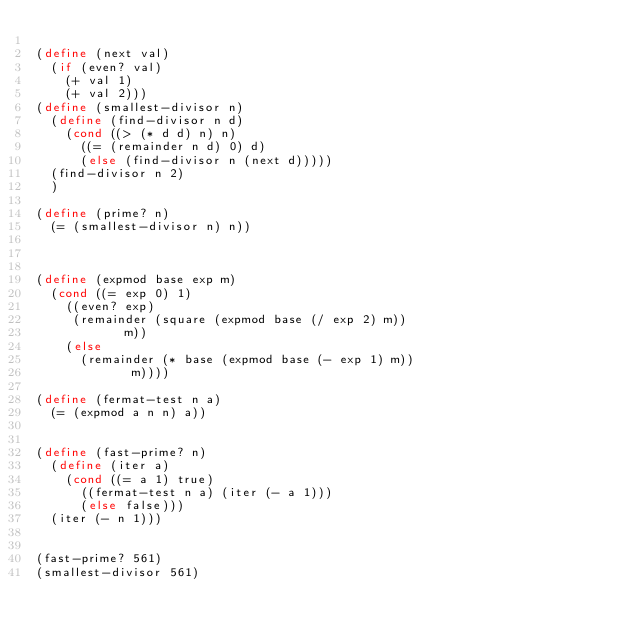<code> <loc_0><loc_0><loc_500><loc_500><_Scheme_>
(define (next val) 
  (if (even? val)
    (+ val 1)
    (+ val 2)))
(define (smallest-divisor n)
  (define (find-divisor n d)
    (cond ((> (* d d) n) n)
	  ((= (remainder n d) 0) d)
	  (else (find-divisor n (next d)))))
  (find-divisor n 2)
  )

(define (prime? n)
  (= (smallest-divisor n) n))



(define (expmod base exp m)
  (cond ((= exp 0) 1)
	((even? exp)
	 (remainder (square (expmod base (/ exp 2) m))
		    m))
	(else
	  (remainder (* base (expmod base (- exp 1) m))
		     m))))

(define (fermat-test n a)
  (= (expmod a n n) a))


(define (fast-prime? n)
  (define (iter a)
    (cond ((= a 1) true)
	  ((fermat-test n a) (iter (- a 1)))
	  (else false)))
  (iter (- n 1)))


(fast-prime? 561)
(smallest-divisor 561)

</code> 